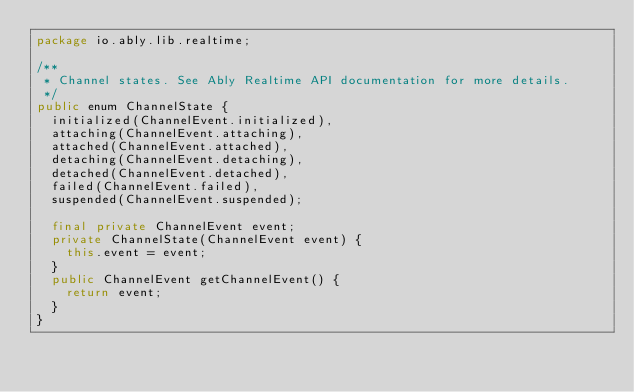<code> <loc_0><loc_0><loc_500><loc_500><_Java_>package io.ably.lib.realtime;

/**
 * Channel states. See Ably Realtime API documentation for more details.
 */
public enum ChannelState {
	initialized(ChannelEvent.initialized),
	attaching(ChannelEvent.attaching),
	attached(ChannelEvent.attached),
	detaching(ChannelEvent.detaching),
	detached(ChannelEvent.detached),
	failed(ChannelEvent.failed),
	suspended(ChannelEvent.suspended);

	final private ChannelEvent event;
	private ChannelState(ChannelEvent event) {
		this.event = event;
	}
	public ChannelEvent getChannelEvent() {
		return event;
	}
}
</code> 